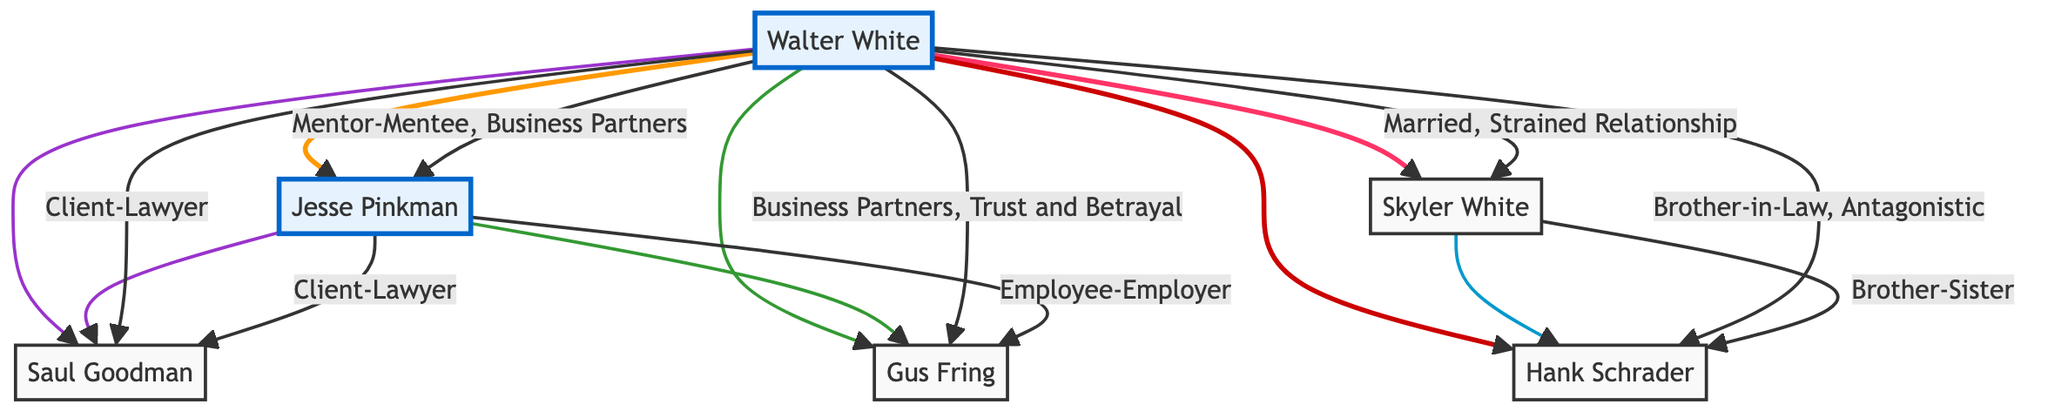What is the primary relationship between Walter White and Jesse Pinkman? The diagram shows a direct link labeled "Mentor-Mentee, Business Partners" between Walter White (A) and Jesse Pinkman (B), indicating that their primary relationship involves mentorship and business collaboration.
Answer: Mentor-Mentee, Business Partners How many main characters are represented in the diagram? The diagram visually highlights two main characters, Walter White and Jesse Pinkman, which are shown using a special color class. There are no other nodes designated as main characters.
Answer: 2 What type of relationship exists between Walter White and Skyler White? The diagram specifies a relationship between Walter White (A) and Skyler White (C) marked as "Married, Strained Relationship." This indicates that their connection is through marriage but is strained.
Answer: Married, Strained Relationship Who is the antagonist in relation to Walter White according to the diagram? The diagram indicates a connection labeled "Business Partners, Trust and Betrayal" between Walter White (A) and Gus Fring (F), where the relationship implies antagonism due to betrayal, suggesting Gus Fring acts antagonistically toward Walter.
Answer: Gus Fring How many distinct relationships are illustrated between Jesse Pinkman and other characters? Counting the connections involving Jesse Pinkman (B), the diagram shows two distinct relationships: one with Walter White (A) and one with Saul Goodman (E) as well as one with Gus Fring (F), totaling three distinct relationships.
Answer: 3 Which character has a strained relationship with Hank Schrader? The diagram indicates a connection labeled "Brother-Sister" between Skyler White (C) and Hank Schrader (D), but there's no label indicating a strained relationship with Hank directly, thus Skyler is the only character with a familial connection to Hank depicted.
Answer: Skyler White What is the labeled connection between Jesse Pinkman and Saul Goodman? The diagram specifies a connection labeled "Client-Lawyer" between Jesse Pinkman (B) and Saul Goodman (E), which defines their primary relationship based on Jesse being a client to Saul's legal services.
Answer: Client-Lawyer Which character serves as a lawyer for Walter White? Walter White (A) has a direct connection to Saul Goodman (E) as indicated by the labeled relationship "Client-Lawyer." This directly shows that Saul Goodman functions as Walter's lawyer.
Answer: Saul Goodman What is the relationship label between Skyler White and Hank Schrader? The diagram directly lists "Brother-Sister" as the relationship label between Skyler White (C) and Hank Schrader (D), defining their familial tie.
Answer: Brother-Sister 